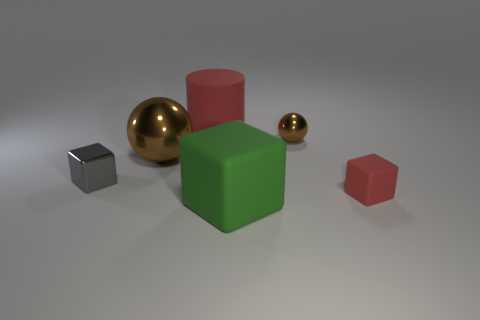How many small shiny objects have the same color as the big metal object?
Give a very brief answer. 1. There is a small gray object; are there any rubber blocks to the right of it?
Offer a terse response. Yes. Is the number of brown spheres that are on the right side of the red rubber cylinder the same as the number of brown metallic things in front of the red rubber cube?
Your response must be concise. No. There is a rubber thing in front of the tiny red object; does it have the same size as the red thing that is to the right of the green rubber thing?
Your answer should be very brief. No. What is the shape of the shiny object that is behind the large ball that is in front of the red object that is behind the metallic block?
Your answer should be compact. Sphere. What is the size of the green object that is the same shape as the tiny gray thing?
Your answer should be very brief. Large. What is the color of the big object that is both in front of the small sphere and left of the large green object?
Ensure brevity in your answer.  Brown. Are the big red cylinder and the tiny object that is in front of the gray block made of the same material?
Ensure brevity in your answer.  Yes. Are there fewer objects that are on the right side of the tiny gray metallic object than big red metal spheres?
Your answer should be very brief. No. What number of other things are there of the same shape as the gray shiny object?
Keep it short and to the point. 2. 